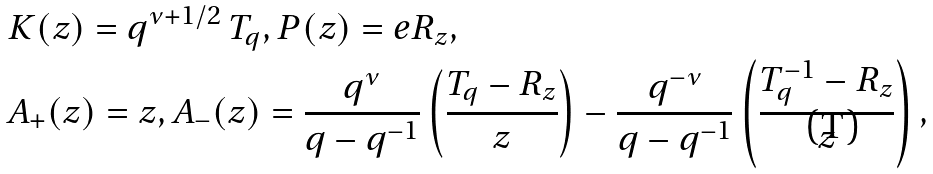Convert formula to latex. <formula><loc_0><loc_0><loc_500><loc_500>& K ( z ) = q ^ { \nu + 1 / 2 } \, T _ { q } , P ( z ) = e R _ { z } , \\ & A _ { + } ( z ) = z , A _ { - } ( z ) = \frac { q ^ { \nu } } { q - q ^ { - 1 } } \left ( \frac { T _ { q } - R _ { z } } { z } \right ) - \frac { q ^ { - \nu } } { q - q ^ { - 1 } } \left ( \frac { T _ { q } ^ { - 1 } - R _ { z } } { z } \right ) ,</formula> 